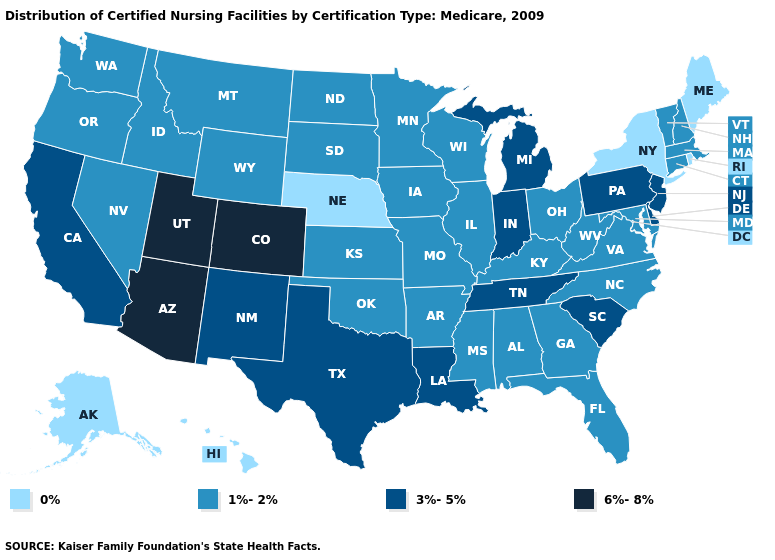Among the states that border Colorado , does Utah have the highest value?
Quick response, please. Yes. Among the states that border Delaware , does Pennsylvania have the lowest value?
Keep it brief. No. Is the legend a continuous bar?
Concise answer only. No. Which states have the lowest value in the MidWest?
Give a very brief answer. Nebraska. What is the highest value in the South ?
Write a very short answer. 3%-5%. What is the highest value in the USA?
Keep it brief. 6%-8%. What is the value of Texas?
Keep it brief. 3%-5%. What is the lowest value in the MidWest?
Short answer required. 0%. Does Indiana have the highest value in the MidWest?
Quick response, please. Yes. What is the value of New Hampshire?
Write a very short answer. 1%-2%. What is the value of Wisconsin?
Give a very brief answer. 1%-2%. What is the highest value in states that border North Carolina?
Answer briefly. 3%-5%. Name the states that have a value in the range 3%-5%?
Quick response, please. California, Delaware, Indiana, Louisiana, Michigan, New Jersey, New Mexico, Pennsylvania, South Carolina, Tennessee, Texas. How many symbols are there in the legend?
Write a very short answer. 4. What is the value of Maine?
Short answer required. 0%. 